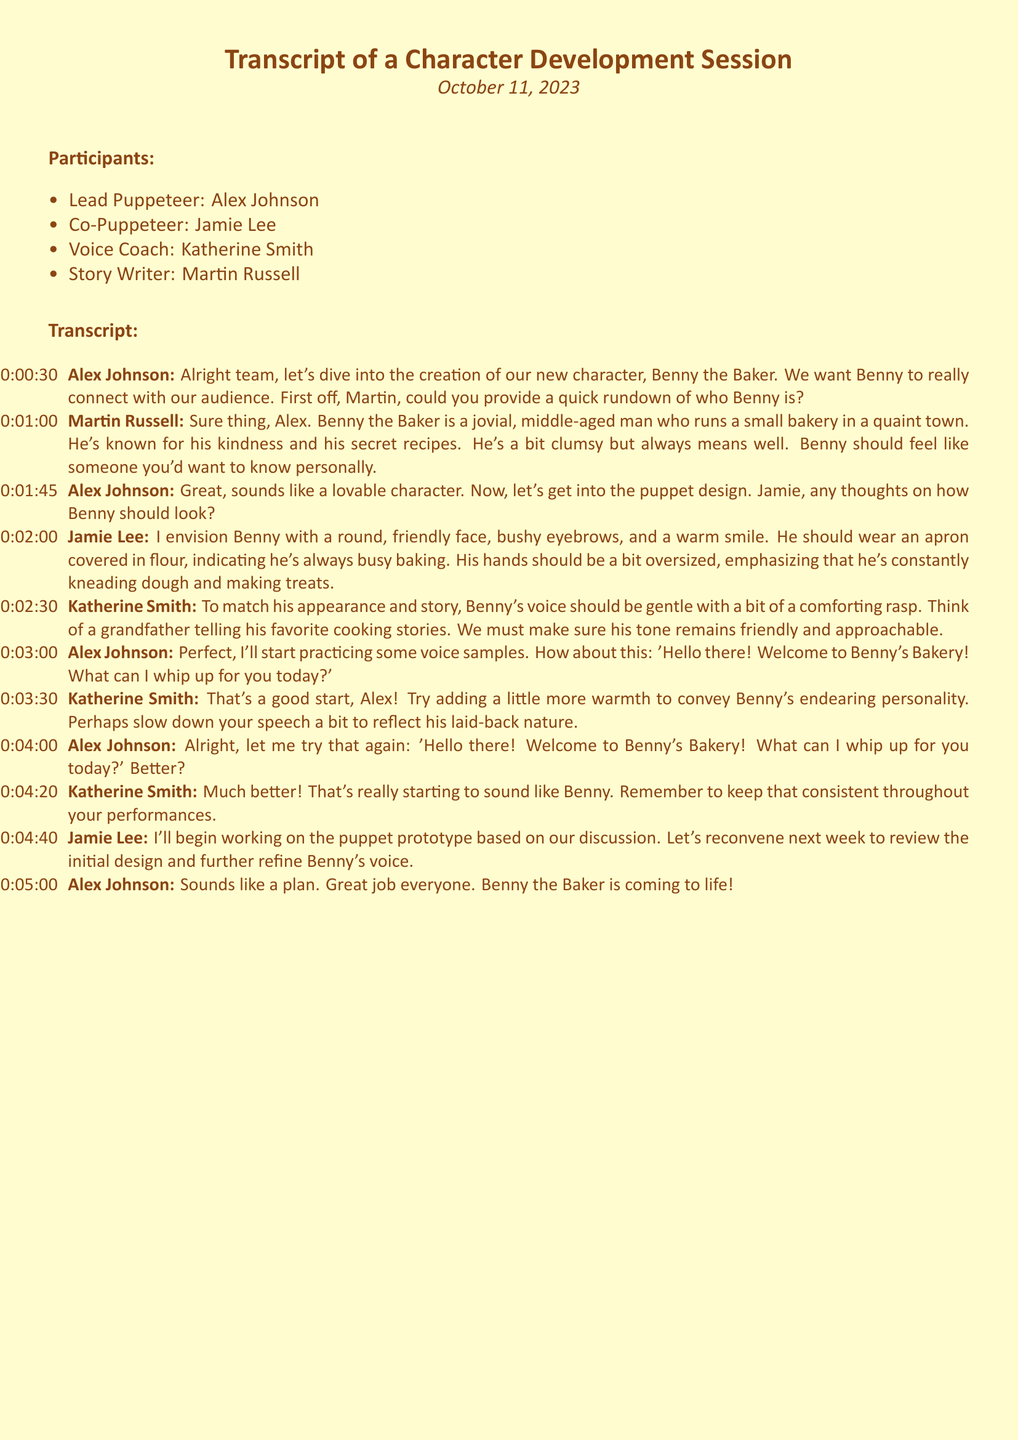What is the name of the new character being developed? The new character being developed is referenced at the beginning of the transcript as Benny the Baker.
Answer: Benny the Baker Who is the lead puppeteer? The lead puppeteer is mentioned in the participants list as Alex Johnson.
Answer: Alex Johnson What trait defines Benny the Baker's personality? Benny is described as jovial, kind, and a bit clumsy, creating a lovable character for the audience.
Answer: Jovial, kind, clumsy What color is associated with the puppet's appearance? The puppet design conversation involves Benny's friendly traits, but specific colors are not mentioned, focusing instead on features like a round face and oversized hands.
Answer: Not specified What is the primary goal for Benny's voice according to Katherine? Katherine emphasizes that Benny's voice should be gentle with a comforting rasp to engagingly connect with the audience.
Answer: Gentle with a comforting rasp When is the next meeting planned to review the puppet prototype? The timeline for reconvening is mentioned towards the end of the document, suggesting next week for a review of Benny's voice and design.
Answer: Next week What type of attire will Benny the Baker wear? Jamie mentions that Benny should wear an apron covered in flour, indicating his busy baking lifestyle.
Answer: An apron covered in flour Which phrase does Alex try to practice for Benny's voice? The specific phrase Alex uses for practice reflects Benny's welcoming nature toward customers in the bakery.
Answer: "Hello there! Welcome to Benny's Bakery! What can I whip up for you today?" What does Katherine advise Alex to add to his voice acting? Katherine suggests that Alex should add warmth to his voice to enhance the endearing personality of Benny.
Answer: More warmth 